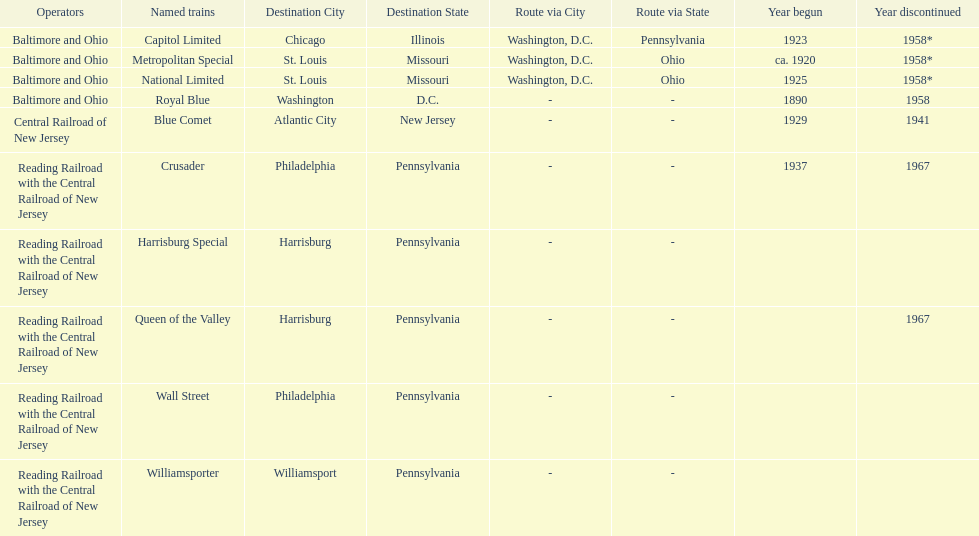What was the first train to begin service? Royal Blue. 